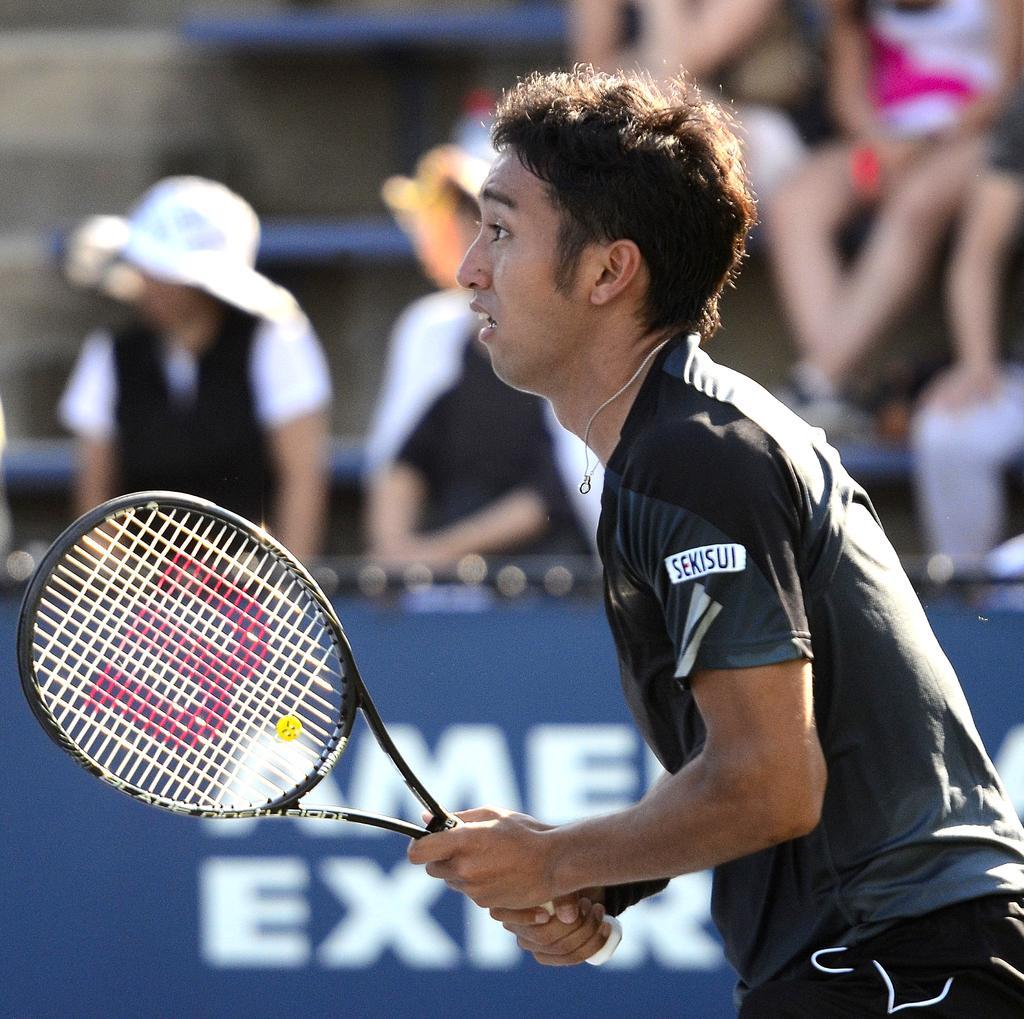Describe this image in one or two sentences. In this image I can see the person is holding the racket. He is wearing the black t-shirt and black short. At the back side few people sitting on the bench. I can see a blue banner. 